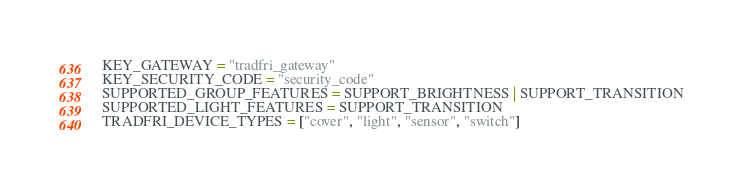<code> <loc_0><loc_0><loc_500><loc_500><_Python_>KEY_GATEWAY = "tradfri_gateway"
KEY_SECURITY_CODE = "security_code"
SUPPORTED_GROUP_FEATURES = SUPPORT_BRIGHTNESS | SUPPORT_TRANSITION
SUPPORTED_LIGHT_FEATURES = SUPPORT_TRANSITION
TRADFRI_DEVICE_TYPES = ["cover", "light", "sensor", "switch"]
</code> 